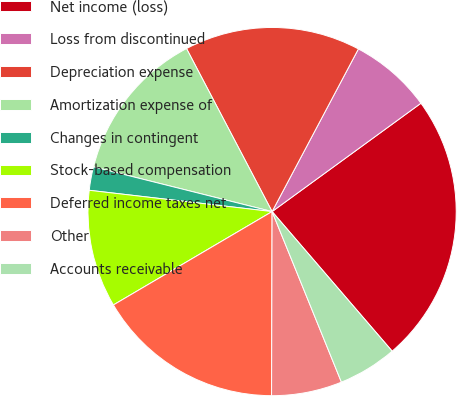Convert chart. <chart><loc_0><loc_0><loc_500><loc_500><pie_chart><fcel>Net income (loss)<fcel>Loss from discontinued<fcel>Depreciation expense<fcel>Amortization expense of<fcel>Changes in contingent<fcel>Stock-based compensation<fcel>Deferred income taxes net<fcel>Other<fcel>Accounts receivable<nl><fcel>23.71%<fcel>7.22%<fcel>15.46%<fcel>13.4%<fcel>2.06%<fcel>10.31%<fcel>16.49%<fcel>6.19%<fcel>5.16%<nl></chart> 